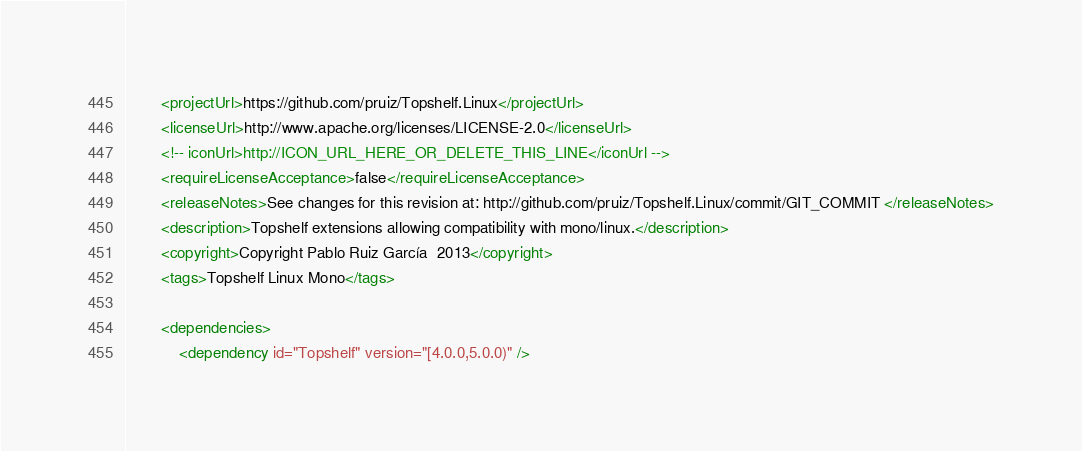<code> <loc_0><loc_0><loc_500><loc_500><_XML_>		<projectUrl>https://github.com/pruiz/Topshelf.Linux</projectUrl>
		<licenseUrl>http://www.apache.org/licenses/LICENSE-2.0</licenseUrl>
		<!-- iconUrl>http://ICON_URL_HERE_OR_DELETE_THIS_LINE</iconUrl -->
		<requireLicenseAcceptance>false</requireLicenseAcceptance>
		<releaseNotes>See changes for this revision at: http://github.com/pruiz/Topshelf.Linux/commit/GIT_COMMIT </releaseNotes>
		<description>Topshelf extensions allowing compatibility with mono/linux.</description>
		<copyright>Copyright Pablo Ruiz García  2013</copyright>
		<tags>Topshelf Linux Mono</tags>

		<dependencies>
			<dependency id="Topshelf" version="[4.0.0,5.0.0)" /></code> 